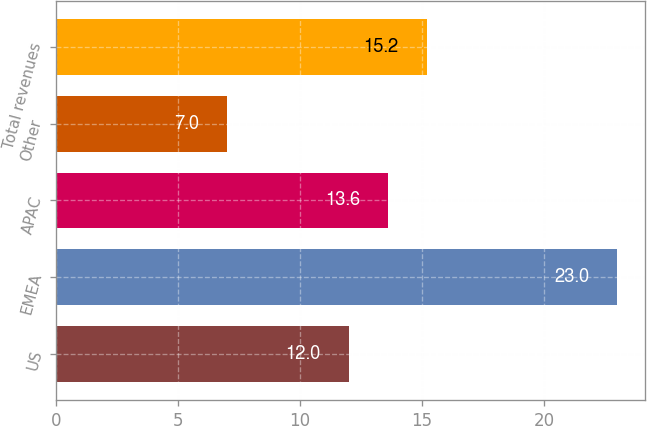Convert chart to OTSL. <chart><loc_0><loc_0><loc_500><loc_500><bar_chart><fcel>US<fcel>EMEA<fcel>APAC<fcel>Other<fcel>Total revenues<nl><fcel>12<fcel>23<fcel>13.6<fcel>7<fcel>15.2<nl></chart> 